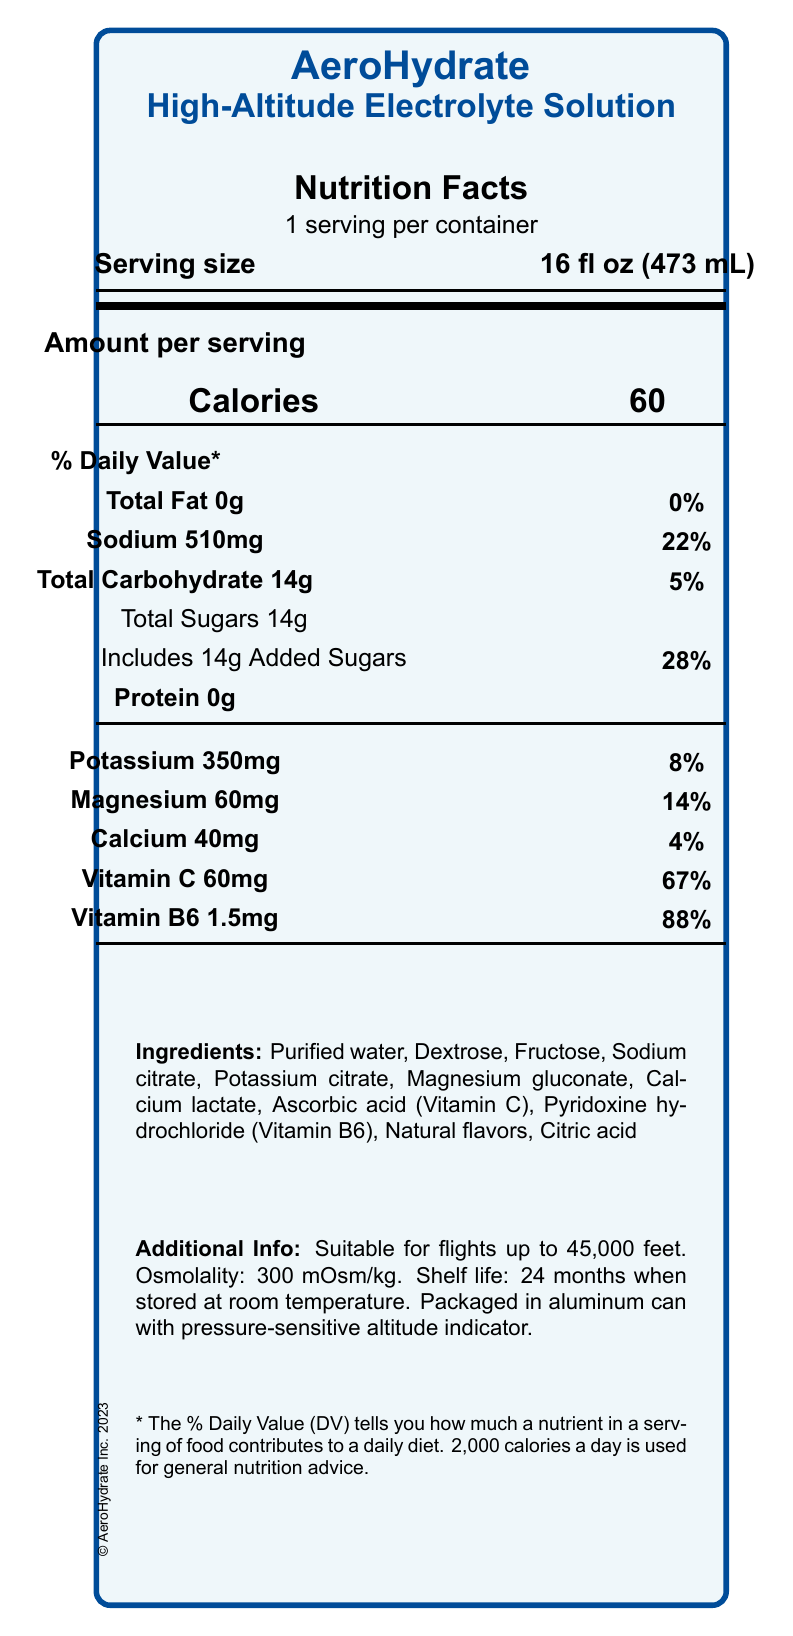what is the serving size of AeroHydrate? The serving size is listed as "16 fl oz (473 mL)" near the top of the document, under the product name.
Answer: 16 fl oz (473 mL) how many calories are in one serving of AeroHydrate? The number of calories per serving is listed as "60" under the section labeled "Amount per serving."
Answer: 60 what percentage of the daily value of sodium does one serving provide? It is indicated that the sodium content per serving is 510mg, which is 22% of the daily value.
Answer: 22% what is the osmolality of AeroHydrate? The osmolality is stated in the additional info section as "Osmolality: 300 mOsm/kg."
Answer: 300 mOsm/kg which vitamin is included in the highest amount based on daily value percentages? Vitamin B6 is listed as providing 88% of the daily value, which is the highest among the vitamins listed.
Answer: Vitamin B6 what are the main ingredients in AeroHydrate? A. Purified water, Dextrose, Fructose B. Sodium citrate, Potassium citrate, Magnesium gluconate C. Dextrose, Fructose, Natural flavors, Citric acid D. All of the above All these ingredients are part of the listed ingredients in the document.
Answer: D what is the total amount of sugars in AeroHydrate per serving? A. 10g B. 14g C. 16g D. 20g The total amount of sugars per serving is listed as 14g under the "Total Sugars" section.
Answer: B does the drink contain any protein? The protein content is listed as "0g," indicating the drink contains no protein.
Answer: No summarize the document. The document is a nutritional facts label for AeroHydrate, covering various nutritional aspects like calories, fats, sugars, and vitamins, as well as additional details relevant to its use in high-altitude environments.
Answer: The document provides detailed nutritional information and additional technical specifications for AeroHydrate, a specialized electrolyte beverage designed for high-altitude flights. It includes data on serving size, calorie content, macronutrients, vitamins, minerals, and ingredients, as well as information on the product's suitability for high-altitude use, osmolality, and packaging. what is the magnesium content in one serving of AeroHydrate? The magnesium content per serving is listed as "60mg," which is 14% of the daily value.
Answer: 60mg how many months is the shelf life of AeroHydrate when stored at room temperature? The shelf life is stated as "24 months when stored at room temperature" in the additional info section.
Answer: 24 months is this beverage suitable for flights exceeding 45,000 feet? The beverage is stated to be suitable for flights up to 45,000 feet, as mentioned in the additional info section.
Answer: No does the document mention the price of AeroHydrate? The document does not provide any details on the price of AeroHydrate.
Answer: Not enough information 